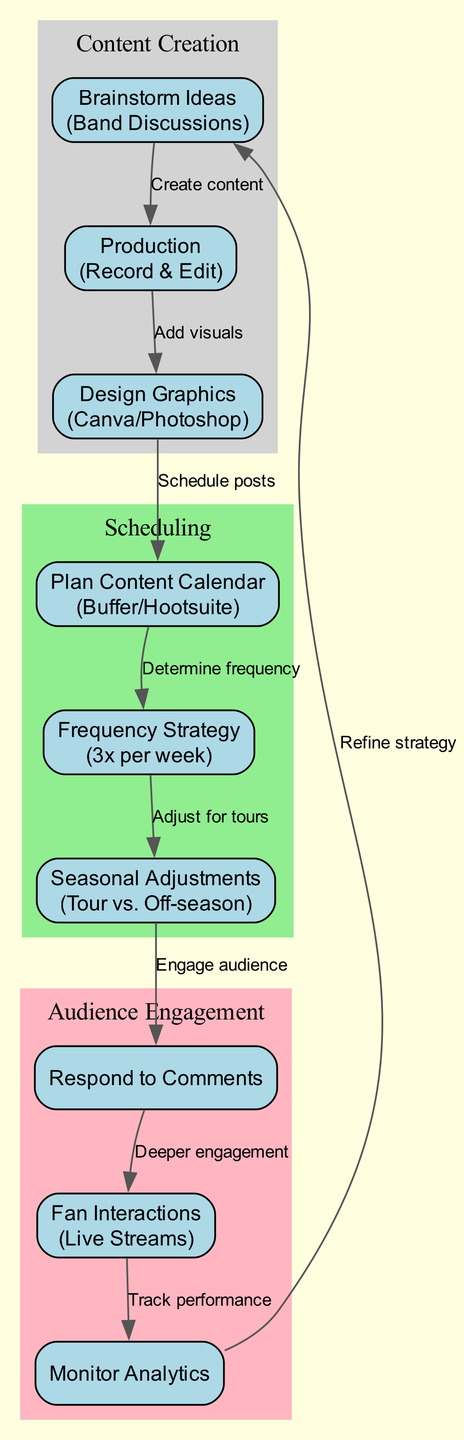What's the first node in the diagram? The first node in the diagram is 'Brainstorm Ideas (Band Discussions)' under the 'Content Creation' section, which is the initial step in the process for maintaining social media presence.
Answer: Brainstorm Ideas (Band Discussions) How many nodes are there in total? By counting each node in the diagram, there are nine total nodes across three main sections: Content Creation, Scheduling, and Audience Engagement.
Answer: Nine What is the relationship between 'Production' and 'Design Graphics'? The relationship is that 'Production' leads to 'Design Graphics' by the directed edge labeled 'Add visuals', indicating that after content production, visuals are added for better presentation.
Answer: Add visuals What strategies are considered in the 'Frequency Strategy' node? The 'Frequency Strategy' node outlines the posting frequency decided in the planning phase, indicating a specific example of posting three times per week including a live Q&A and performance clips.
Answer: 3 times per week Which node monitors audience interactions? The node that monitors audience interactions is 'Monitor Analytics', which focuses on tracking engagement metrics to adjust strategies based on audience response to content.
Answer: Monitor Analytics What is adjusted during touring seasons according to the diagram? The 'Seasonal Adjustments' node indicates that the posting schedule will be adjusted during touring seasons, with more frequent updates to engage fans during those active periods.
Answer: Posting schedule Which node directly leads to 'Respond to Comments'? The 'Seasonal Adjustments' node directly leads to 'Respond to Comments', indicating that adjustments in posting frequency impact how and when the audience engagement occurs.
Answer: Seasonal Adjustments What is the purpose of the 'Fan Interactions' node? The purpose of the 'Fan Interactions' node is to engage with fans through live streams, creating real-time connections by sharing stories and music, which is essential for increasing audience engagement.
Answer: Engage with fans How does the diagram suggest refining strategies? The diagram suggests refining strategies by showing that 'Monitor Analytics' leads back to 'Brainstorm Ideas', indicating that the analysis of past success informs future content creation strategies.
Answer: Refine strategy 